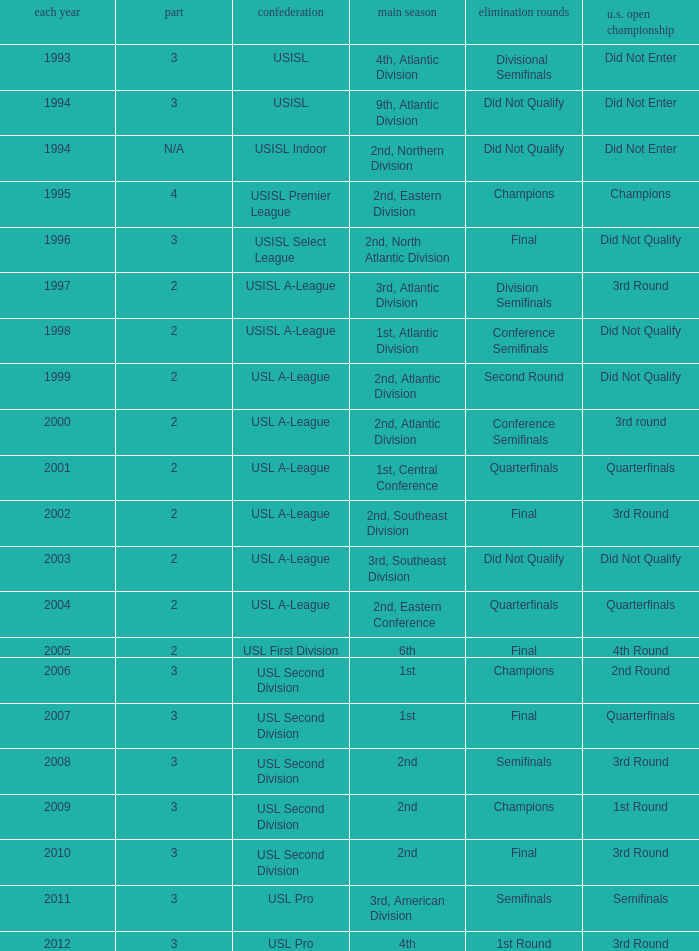Which round is u.s. open cup division semifinals 3rd Round. 